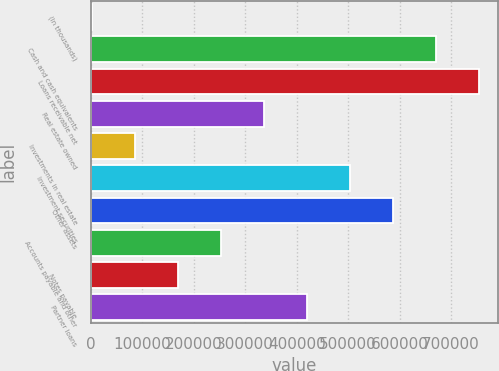<chart> <loc_0><loc_0><loc_500><loc_500><bar_chart><fcel>(In thousands)<fcel>Cash and cash equivalents<fcel>Loans receivable net<fcel>Real estate owned<fcel>Investments in real estate<fcel>Investment securities<fcel>Other assets<fcel>Accounts payable and other<fcel>Notes payable<fcel>Partner loans<nl><fcel>2012<fcel>670553<fcel>754120<fcel>336282<fcel>85579.6<fcel>503418<fcel>586985<fcel>252715<fcel>169147<fcel>419850<nl></chart> 